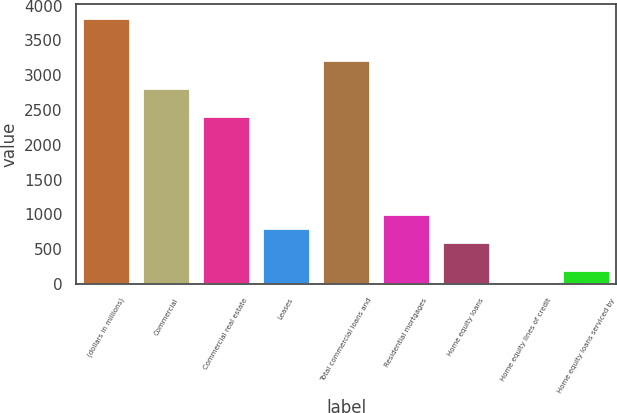Convert chart to OTSL. <chart><loc_0><loc_0><loc_500><loc_500><bar_chart><fcel>(dollars in millions)<fcel>Commercial<fcel>Commercial real estate<fcel>Leases<fcel>Total commercial loans and<fcel>Residential mortgages<fcel>Home equity loans<fcel>Home equity lines of credit<fcel>Home equity loans serviced by<nl><fcel>3828.7<fcel>2822.2<fcel>2419.6<fcel>809.2<fcel>3224.8<fcel>1010.5<fcel>607.9<fcel>4<fcel>205.3<nl></chart> 